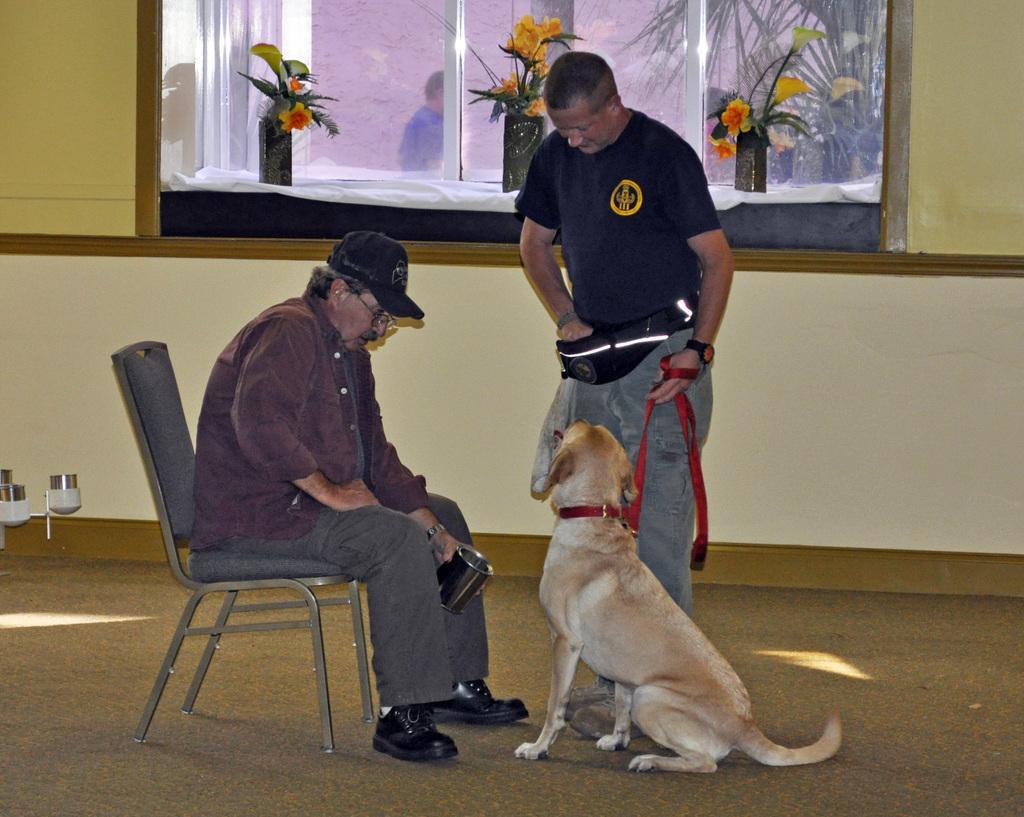Could you give a brief overview of what you see in this image? There are 2 people,one and two on the right of the person is standing. He's holding a dog cloth. On the left side of the person is sitting in a chair. He's wearing a cap. He's holding a glass. There was dog in front of him. The background we can beautiful flower vases,window is there. 